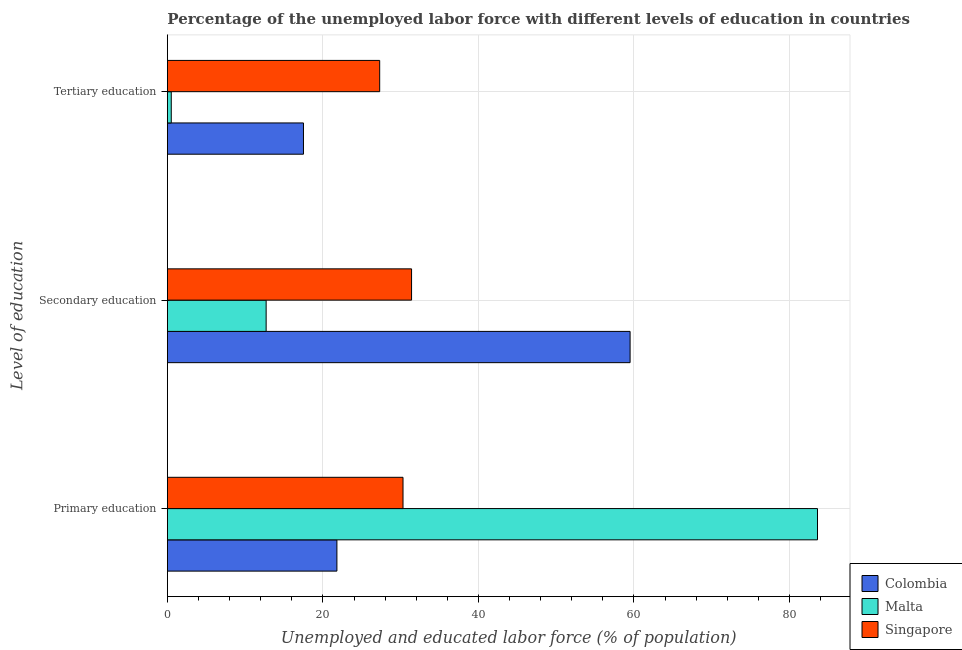How many groups of bars are there?
Ensure brevity in your answer.  3. Are the number of bars per tick equal to the number of legend labels?
Your response must be concise. Yes. Are the number of bars on each tick of the Y-axis equal?
Provide a short and direct response. Yes. How many bars are there on the 3rd tick from the top?
Offer a terse response. 3. How many bars are there on the 3rd tick from the bottom?
Your answer should be very brief. 3. What is the label of the 2nd group of bars from the top?
Give a very brief answer. Secondary education. What is the percentage of labor force who received primary education in Singapore?
Give a very brief answer. 30.3. Across all countries, what is the maximum percentage of labor force who received tertiary education?
Provide a succinct answer. 27.3. Across all countries, what is the minimum percentage of labor force who received tertiary education?
Give a very brief answer. 0.5. In which country was the percentage of labor force who received tertiary education maximum?
Make the answer very short. Singapore. What is the total percentage of labor force who received secondary education in the graph?
Keep it short and to the point. 103.6. What is the difference between the percentage of labor force who received tertiary education in Singapore and that in Malta?
Make the answer very short. 26.8. What is the difference between the percentage of labor force who received primary education in Colombia and the percentage of labor force who received secondary education in Singapore?
Provide a succinct answer. -9.6. What is the average percentage of labor force who received secondary education per country?
Offer a terse response. 34.53. What is the difference between the percentage of labor force who received tertiary education and percentage of labor force who received secondary education in Malta?
Offer a very short reply. -12.2. In how many countries, is the percentage of labor force who received primary education greater than 32 %?
Your answer should be very brief. 1. What is the ratio of the percentage of labor force who received primary education in Colombia to that in Malta?
Give a very brief answer. 0.26. Is the difference between the percentage of labor force who received secondary education in Colombia and Malta greater than the difference between the percentage of labor force who received tertiary education in Colombia and Malta?
Keep it short and to the point. Yes. What is the difference between the highest and the second highest percentage of labor force who received tertiary education?
Offer a terse response. 9.8. What is the difference between the highest and the lowest percentage of labor force who received primary education?
Offer a terse response. 61.8. Is the sum of the percentage of labor force who received secondary education in Colombia and Malta greater than the maximum percentage of labor force who received primary education across all countries?
Your response must be concise. No. What does the 2nd bar from the bottom in Secondary education represents?
Keep it short and to the point. Malta. How many bars are there?
Your answer should be very brief. 9. Are all the bars in the graph horizontal?
Provide a succinct answer. Yes. What is the difference between two consecutive major ticks on the X-axis?
Your answer should be compact. 20. Are the values on the major ticks of X-axis written in scientific E-notation?
Make the answer very short. No. Does the graph contain any zero values?
Keep it short and to the point. No. How many legend labels are there?
Give a very brief answer. 3. What is the title of the graph?
Make the answer very short. Percentage of the unemployed labor force with different levels of education in countries. Does "Tonga" appear as one of the legend labels in the graph?
Your answer should be very brief. No. What is the label or title of the X-axis?
Make the answer very short. Unemployed and educated labor force (% of population). What is the label or title of the Y-axis?
Make the answer very short. Level of education. What is the Unemployed and educated labor force (% of population) in Colombia in Primary education?
Keep it short and to the point. 21.8. What is the Unemployed and educated labor force (% of population) of Malta in Primary education?
Offer a very short reply. 83.6. What is the Unemployed and educated labor force (% of population) of Singapore in Primary education?
Provide a succinct answer. 30.3. What is the Unemployed and educated labor force (% of population) in Colombia in Secondary education?
Your answer should be compact. 59.5. What is the Unemployed and educated labor force (% of population) in Malta in Secondary education?
Make the answer very short. 12.7. What is the Unemployed and educated labor force (% of population) in Singapore in Secondary education?
Your response must be concise. 31.4. What is the Unemployed and educated labor force (% of population) in Colombia in Tertiary education?
Offer a very short reply. 17.5. What is the Unemployed and educated labor force (% of population) of Malta in Tertiary education?
Provide a succinct answer. 0.5. What is the Unemployed and educated labor force (% of population) of Singapore in Tertiary education?
Provide a succinct answer. 27.3. Across all Level of education, what is the maximum Unemployed and educated labor force (% of population) of Colombia?
Your response must be concise. 59.5. Across all Level of education, what is the maximum Unemployed and educated labor force (% of population) in Malta?
Provide a succinct answer. 83.6. Across all Level of education, what is the maximum Unemployed and educated labor force (% of population) in Singapore?
Offer a terse response. 31.4. Across all Level of education, what is the minimum Unemployed and educated labor force (% of population) of Colombia?
Ensure brevity in your answer.  17.5. Across all Level of education, what is the minimum Unemployed and educated labor force (% of population) in Malta?
Your response must be concise. 0.5. Across all Level of education, what is the minimum Unemployed and educated labor force (% of population) in Singapore?
Make the answer very short. 27.3. What is the total Unemployed and educated labor force (% of population) of Colombia in the graph?
Your answer should be compact. 98.8. What is the total Unemployed and educated labor force (% of population) in Malta in the graph?
Your response must be concise. 96.8. What is the total Unemployed and educated labor force (% of population) in Singapore in the graph?
Your response must be concise. 89. What is the difference between the Unemployed and educated labor force (% of population) of Colombia in Primary education and that in Secondary education?
Make the answer very short. -37.7. What is the difference between the Unemployed and educated labor force (% of population) in Malta in Primary education and that in Secondary education?
Offer a terse response. 70.9. What is the difference between the Unemployed and educated labor force (% of population) of Colombia in Primary education and that in Tertiary education?
Keep it short and to the point. 4.3. What is the difference between the Unemployed and educated labor force (% of population) in Malta in Primary education and that in Tertiary education?
Offer a very short reply. 83.1. What is the difference between the Unemployed and educated labor force (% of population) of Colombia in Secondary education and that in Tertiary education?
Your answer should be compact. 42. What is the difference between the Unemployed and educated labor force (% of population) in Malta in Secondary education and that in Tertiary education?
Keep it short and to the point. 12.2. What is the difference between the Unemployed and educated labor force (% of population) in Singapore in Secondary education and that in Tertiary education?
Ensure brevity in your answer.  4.1. What is the difference between the Unemployed and educated labor force (% of population) in Malta in Primary education and the Unemployed and educated labor force (% of population) in Singapore in Secondary education?
Your response must be concise. 52.2. What is the difference between the Unemployed and educated labor force (% of population) in Colombia in Primary education and the Unemployed and educated labor force (% of population) in Malta in Tertiary education?
Ensure brevity in your answer.  21.3. What is the difference between the Unemployed and educated labor force (% of population) of Malta in Primary education and the Unemployed and educated labor force (% of population) of Singapore in Tertiary education?
Offer a terse response. 56.3. What is the difference between the Unemployed and educated labor force (% of population) in Colombia in Secondary education and the Unemployed and educated labor force (% of population) in Singapore in Tertiary education?
Make the answer very short. 32.2. What is the difference between the Unemployed and educated labor force (% of population) of Malta in Secondary education and the Unemployed and educated labor force (% of population) of Singapore in Tertiary education?
Your response must be concise. -14.6. What is the average Unemployed and educated labor force (% of population) in Colombia per Level of education?
Give a very brief answer. 32.93. What is the average Unemployed and educated labor force (% of population) of Malta per Level of education?
Your answer should be compact. 32.27. What is the average Unemployed and educated labor force (% of population) in Singapore per Level of education?
Provide a succinct answer. 29.67. What is the difference between the Unemployed and educated labor force (% of population) of Colombia and Unemployed and educated labor force (% of population) of Malta in Primary education?
Provide a short and direct response. -61.8. What is the difference between the Unemployed and educated labor force (% of population) of Malta and Unemployed and educated labor force (% of population) of Singapore in Primary education?
Provide a short and direct response. 53.3. What is the difference between the Unemployed and educated labor force (% of population) of Colombia and Unemployed and educated labor force (% of population) of Malta in Secondary education?
Your answer should be compact. 46.8. What is the difference between the Unemployed and educated labor force (% of population) of Colombia and Unemployed and educated labor force (% of population) of Singapore in Secondary education?
Provide a short and direct response. 28.1. What is the difference between the Unemployed and educated labor force (% of population) in Malta and Unemployed and educated labor force (% of population) in Singapore in Secondary education?
Offer a very short reply. -18.7. What is the difference between the Unemployed and educated labor force (% of population) of Malta and Unemployed and educated labor force (% of population) of Singapore in Tertiary education?
Your answer should be compact. -26.8. What is the ratio of the Unemployed and educated labor force (% of population) in Colombia in Primary education to that in Secondary education?
Offer a very short reply. 0.37. What is the ratio of the Unemployed and educated labor force (% of population) of Malta in Primary education to that in Secondary education?
Make the answer very short. 6.58. What is the ratio of the Unemployed and educated labor force (% of population) in Singapore in Primary education to that in Secondary education?
Provide a short and direct response. 0.96. What is the ratio of the Unemployed and educated labor force (% of population) of Colombia in Primary education to that in Tertiary education?
Provide a succinct answer. 1.25. What is the ratio of the Unemployed and educated labor force (% of population) in Malta in Primary education to that in Tertiary education?
Your response must be concise. 167.2. What is the ratio of the Unemployed and educated labor force (% of population) of Singapore in Primary education to that in Tertiary education?
Your answer should be compact. 1.11. What is the ratio of the Unemployed and educated labor force (% of population) in Malta in Secondary education to that in Tertiary education?
Your answer should be compact. 25.4. What is the ratio of the Unemployed and educated labor force (% of population) in Singapore in Secondary education to that in Tertiary education?
Offer a terse response. 1.15. What is the difference between the highest and the second highest Unemployed and educated labor force (% of population) in Colombia?
Keep it short and to the point. 37.7. What is the difference between the highest and the second highest Unemployed and educated labor force (% of population) in Malta?
Offer a terse response. 70.9. What is the difference between the highest and the lowest Unemployed and educated labor force (% of population) of Malta?
Offer a terse response. 83.1. What is the difference between the highest and the lowest Unemployed and educated labor force (% of population) of Singapore?
Provide a short and direct response. 4.1. 